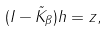<formula> <loc_0><loc_0><loc_500><loc_500>( I - \tilde { K } _ { \beta } ) h = z ,</formula> 